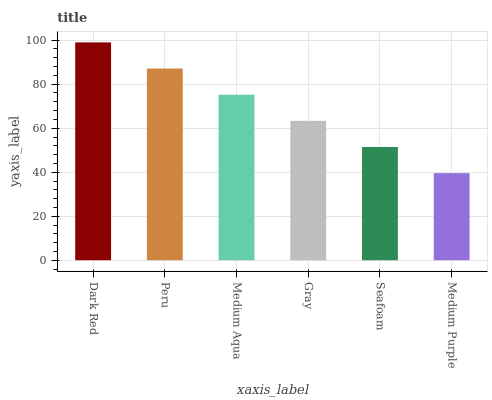Is Peru the minimum?
Answer yes or no. No. Is Peru the maximum?
Answer yes or no. No. Is Dark Red greater than Peru?
Answer yes or no. Yes. Is Peru less than Dark Red?
Answer yes or no. Yes. Is Peru greater than Dark Red?
Answer yes or no. No. Is Dark Red less than Peru?
Answer yes or no. No. Is Medium Aqua the high median?
Answer yes or no. Yes. Is Gray the low median?
Answer yes or no. Yes. Is Medium Purple the high median?
Answer yes or no. No. Is Medium Aqua the low median?
Answer yes or no. No. 